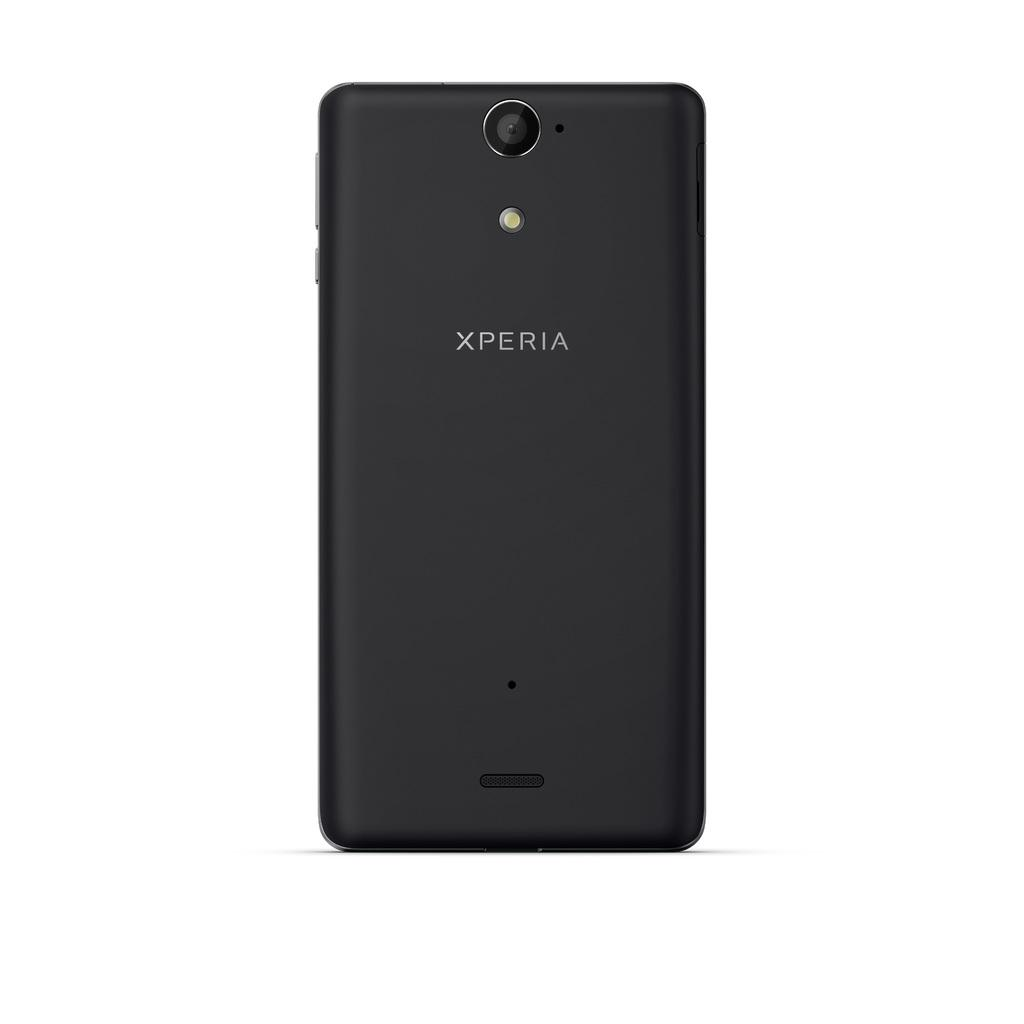<image>
Relay a brief, clear account of the picture shown. A black cellphone made by xperia is facing backward. 